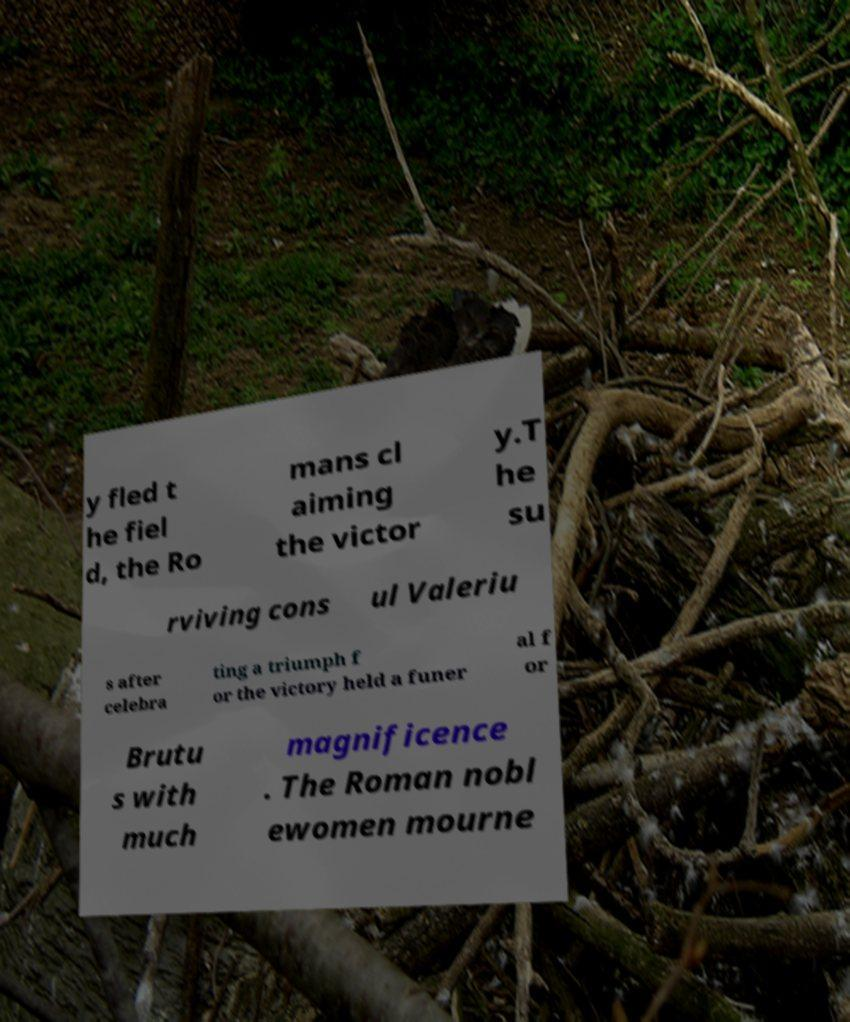There's text embedded in this image that I need extracted. Can you transcribe it verbatim? y fled t he fiel d, the Ro mans cl aiming the victor y.T he su rviving cons ul Valeriu s after celebra ting a triumph f or the victory held a funer al f or Brutu s with much magnificence . The Roman nobl ewomen mourne 